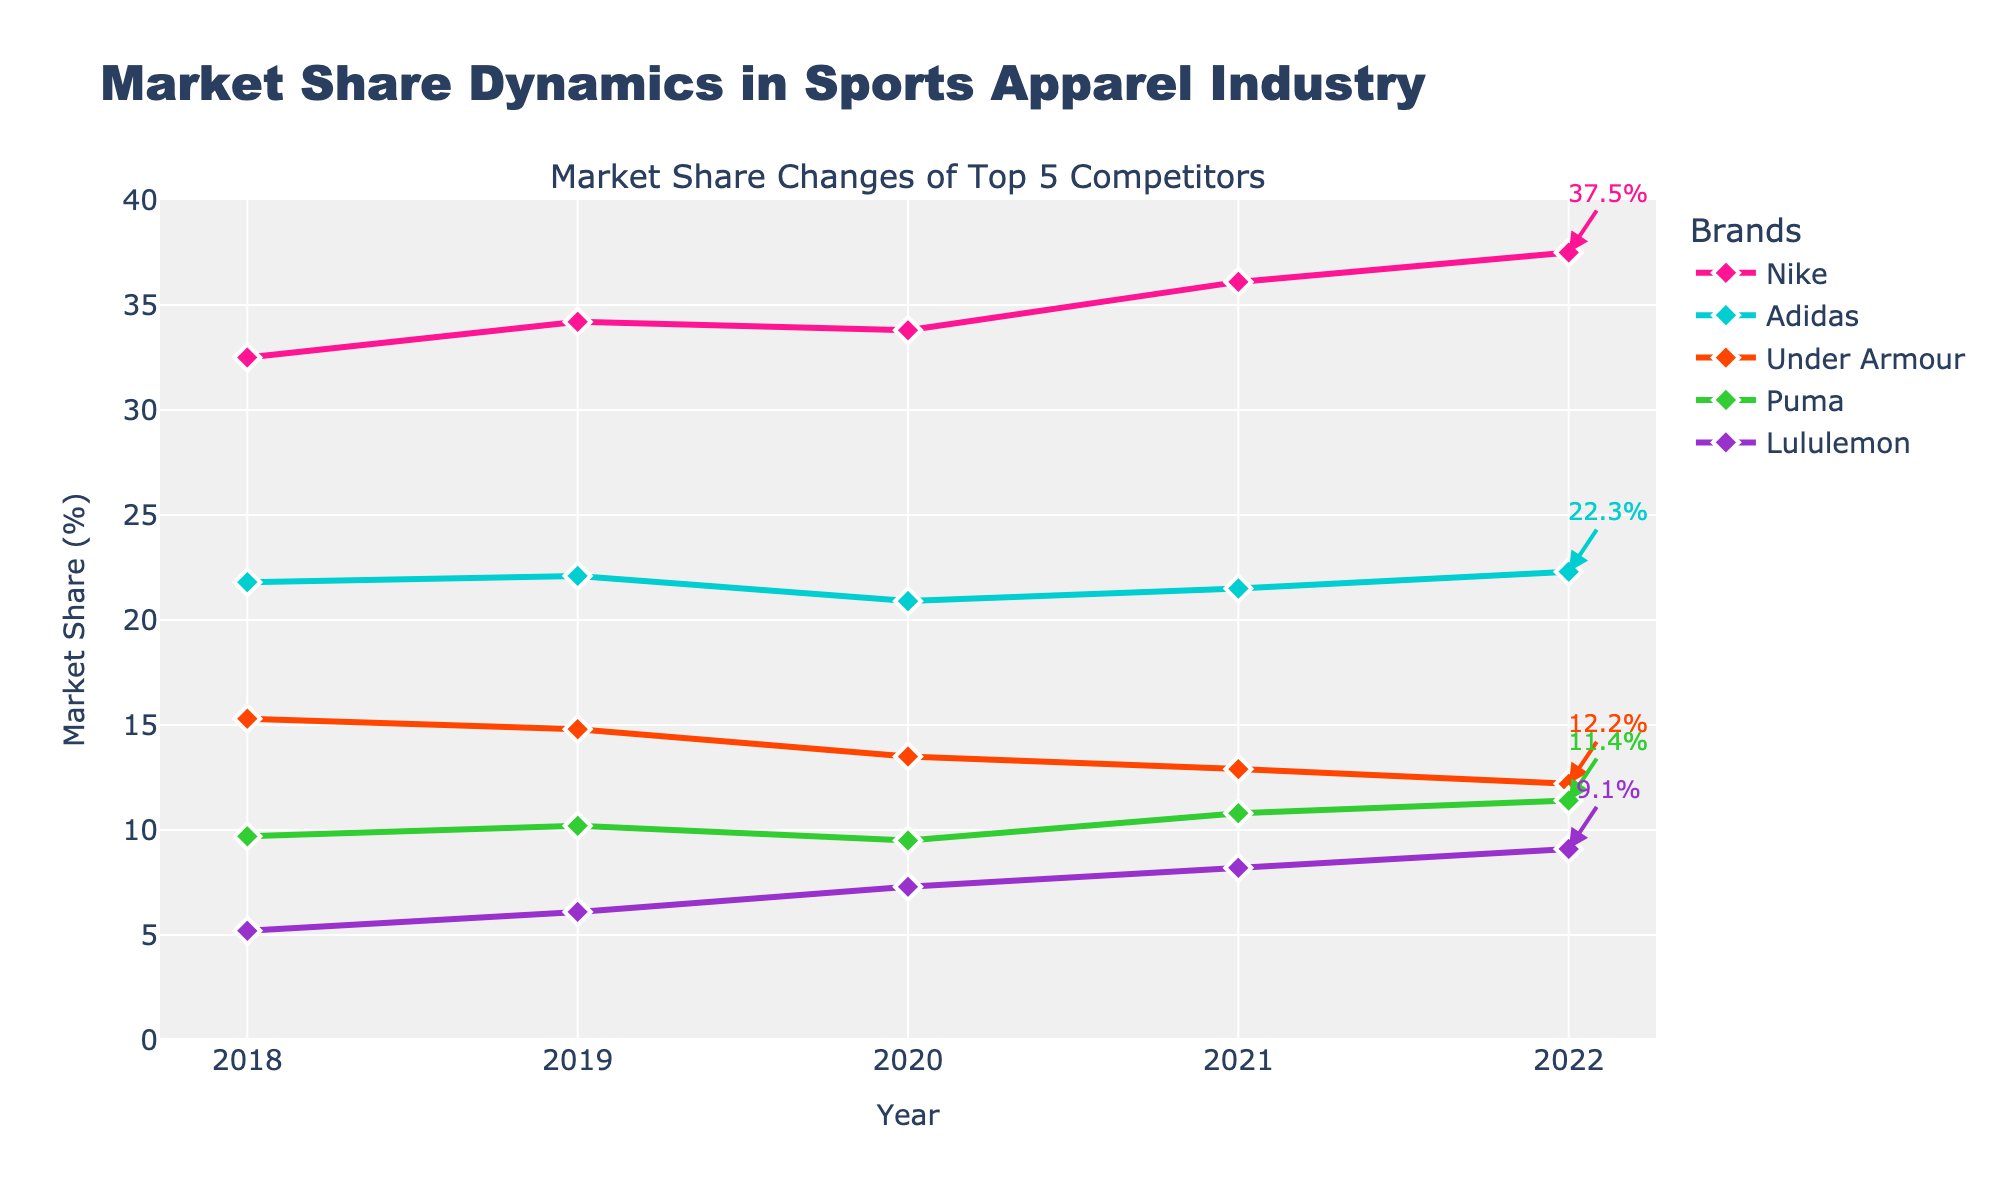What were the market shares of Nike and Adidas in the year 2020? First, locate the year 2020 on the x-axis. Then, find the corresponding y-values on the lines for Nike and Adidas. Nike is 33.8%, and Adidas is 20.9%.
Answer: Nike: 33.8%, Adidas: 20.9% Which brand had the highest market share in 2022, and what was it? Look at the endpoint for each line at the year 2022. Nike has the highest endpoint at 37.5%.
Answer: Nike: 37.5% What is the difference between Nike's market share in 2022 and Under Armour's market share in 2022? Locate the market shares of Nike and Under Armour at the year 2022. Subtract Under Armour's share from Nike's: 37.5% - 12.2% = 25.3%.
Answer: 25.3% Which brand showed the most consistent (least fluctuating) market share trend over the 5 years? Visually inspect the lines for each brand and assess which line is the smoothest or has the least fluctuations. Adidas' line appears to be the most consistent.
Answer: Adidas Between which years did Lululemon see the largest increase in market share? Locate the line for Lululemon and compare the vertical distances between consecutive years. The largest increase is between 2019 and 2020 where the market share increased from 6.1% to 7.3%.
Answer: 2019 to 2020 What is the average market share of Puma over the 5 years shown? Sum Puma's market shares for each year: 9.7 + 10.2 + 9.5 + 10.8 + 11.4 = 51.6. Then divide by the number of years (5). 51.6/5 = 10.32%.
Answer: 10.32% How did Under Armour's market share change from 2018 to 2022? Find the market share of Under Armour in 2018 and compare it to 2022. It dropped from 15.3% to 12.2%.
Answer: Decreased by 3.1% Which brand had the largest market share decline between any two consecutive years? Check the decreases in market shares between consecutive years for all brands. The largest decline is for Under Armour from 2019 to 2020 (14.8% to 13.5%), a decline of 1.3%.
Answer: Under Armour (2019 to 2020) 